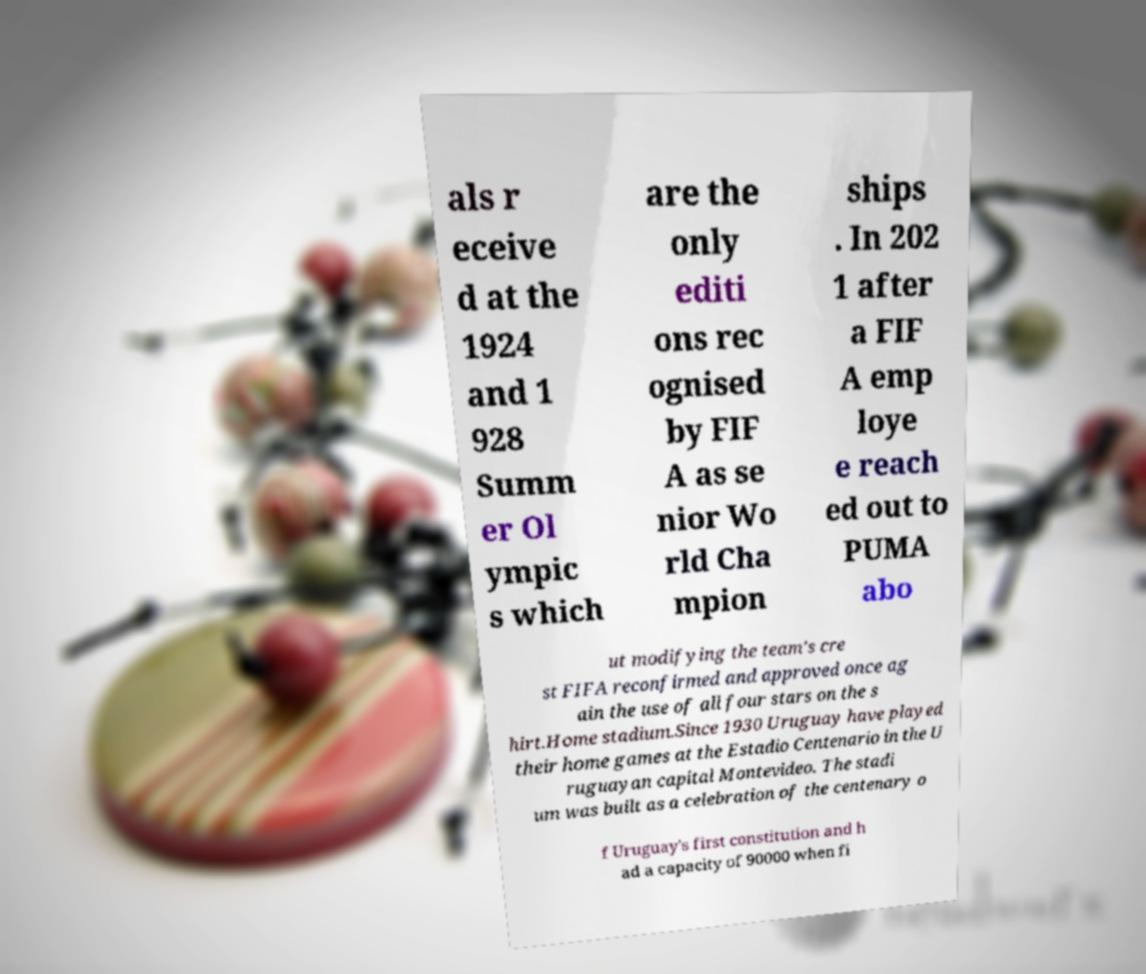Could you extract and type out the text from this image? als r eceive d at the 1924 and 1 928 Summ er Ol ympic s which are the only editi ons rec ognised by FIF A as se nior Wo rld Cha mpion ships . In 202 1 after a FIF A emp loye e reach ed out to PUMA abo ut modifying the team's cre st FIFA reconfirmed and approved once ag ain the use of all four stars on the s hirt.Home stadium.Since 1930 Uruguay have played their home games at the Estadio Centenario in the U ruguayan capital Montevideo. The stadi um was built as a celebration of the centenary o f Uruguay's first constitution and h ad a capacity of 90000 when fi 